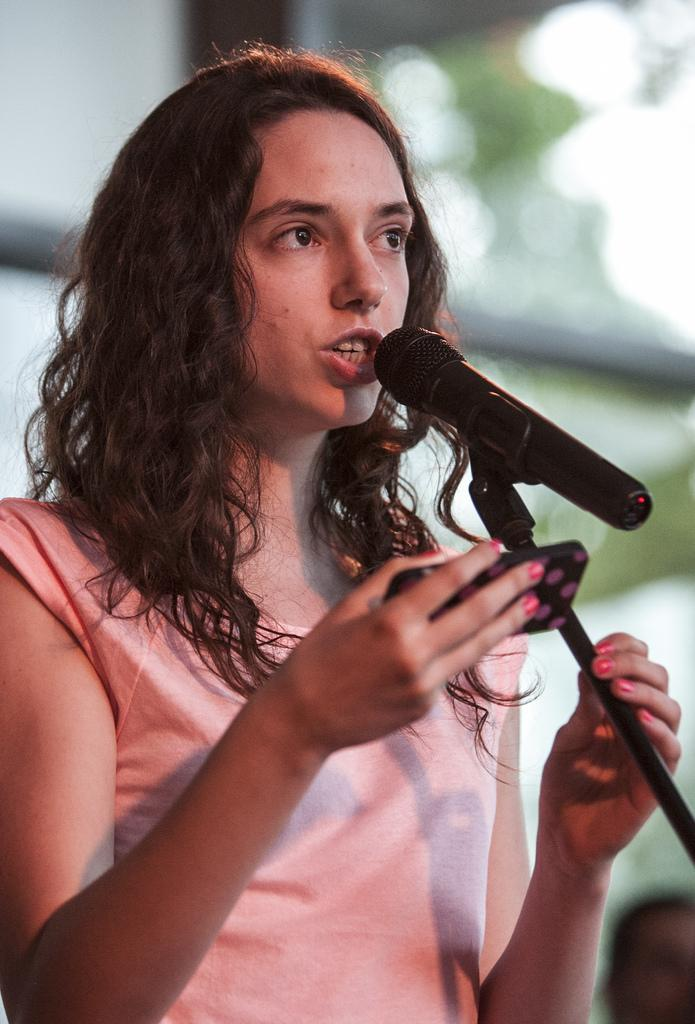What can be seen in the image? There is a person in the image. Can you describe the person's attire? The person is wearing clothes. What is the person holding in her hand? The person is holding a phone in her hand. What object is on the right side of the image? There is a mic on the right side of the image. How would you describe the background of the image? The background of the image is blurred. What type of lead is the person using to write in the image? There is no lead or writing instrument visible in the image. What color is the rose on the left side of the image? There is no rose present in the image. 